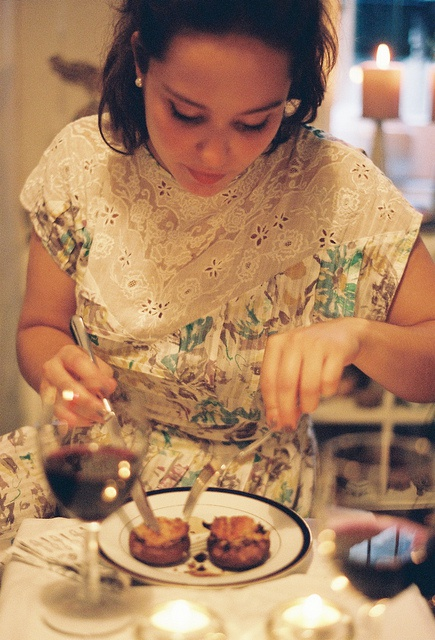Describe the objects in this image and their specific colors. I can see people in gray, brown, tan, and black tones, wine glass in gray, brown, tan, and black tones, wine glass in gray, brown, and black tones, dining table in gray and tan tones, and donut in gray, brown, maroon, salmon, and black tones in this image. 